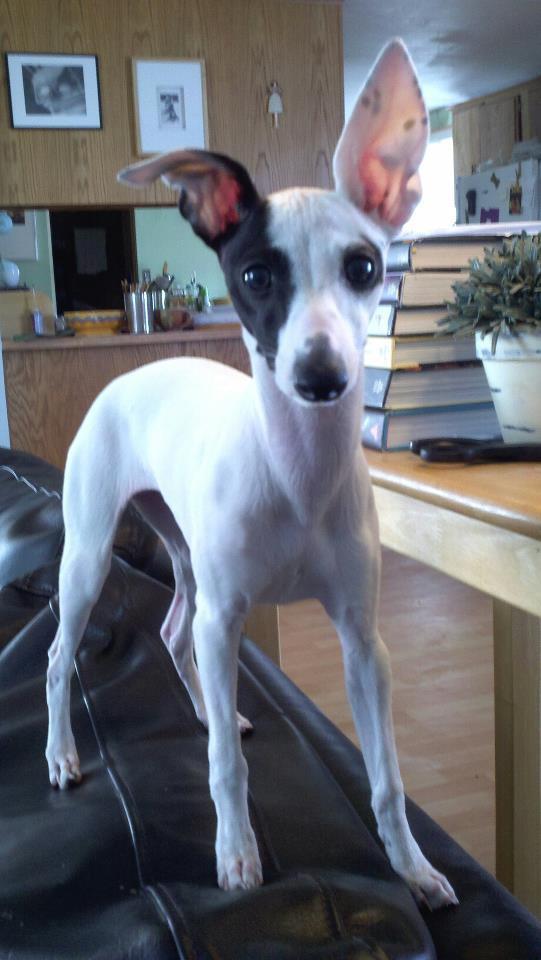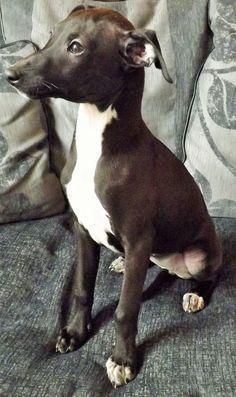The first image is the image on the left, the second image is the image on the right. For the images displayed, is the sentence "At least one of the dog is wearing a collar." factually correct? Answer yes or no. No. The first image is the image on the left, the second image is the image on the right. Examine the images to the left and right. Is the description "One image shows a dog sitting upright, and the other shows at least one dog standing on all fours." accurate? Answer yes or no. Yes. 